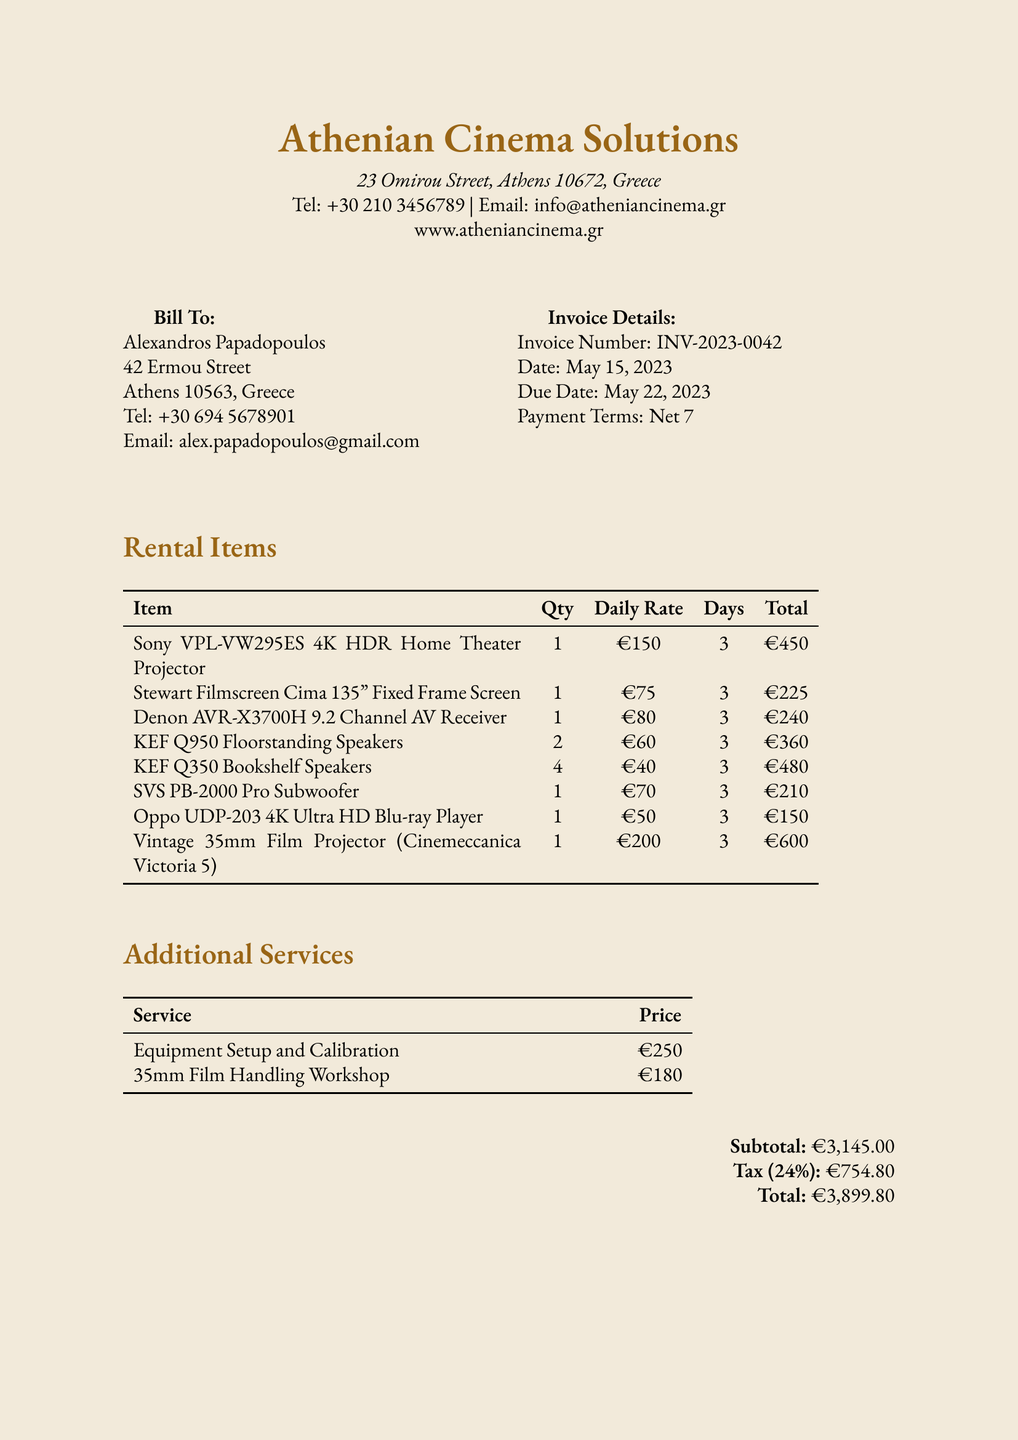What is the invoice number? The invoice number is listed in the invoice details section of the document.
Answer: INV-2023-0042 Who is the customer? The customer's name is found in the bill-to section of the document.
Answer: Alexandros Papadopoulos What is the total amount due? The total amount is a summary figure presented at the end of the document.
Answer: €3,899.80 How many days is the equipment rented for? The rental duration is stated for each item in the document.
Answer: 3 What type of subwoofer is rented? The specific item names are listed under rental items in the document.
Answer: SVS PB-2000 Pro Subwoofer What is the tax rate applied? The tax rate is indicated in the summary of financial details within the document.
Answer: 24% What service is offered to assist with film projection handling? The services section in the document details specific offerings available.
Answer: 35mm Film Handling Workshop How many KEF Q350 bookshelf speakers are rented? The quantity of the item is specified in the rental items table.
Answer: 4 What is the price for Equipment Setup and Calibration? The prices for services are provided in the additional services section.
Answer: €250 